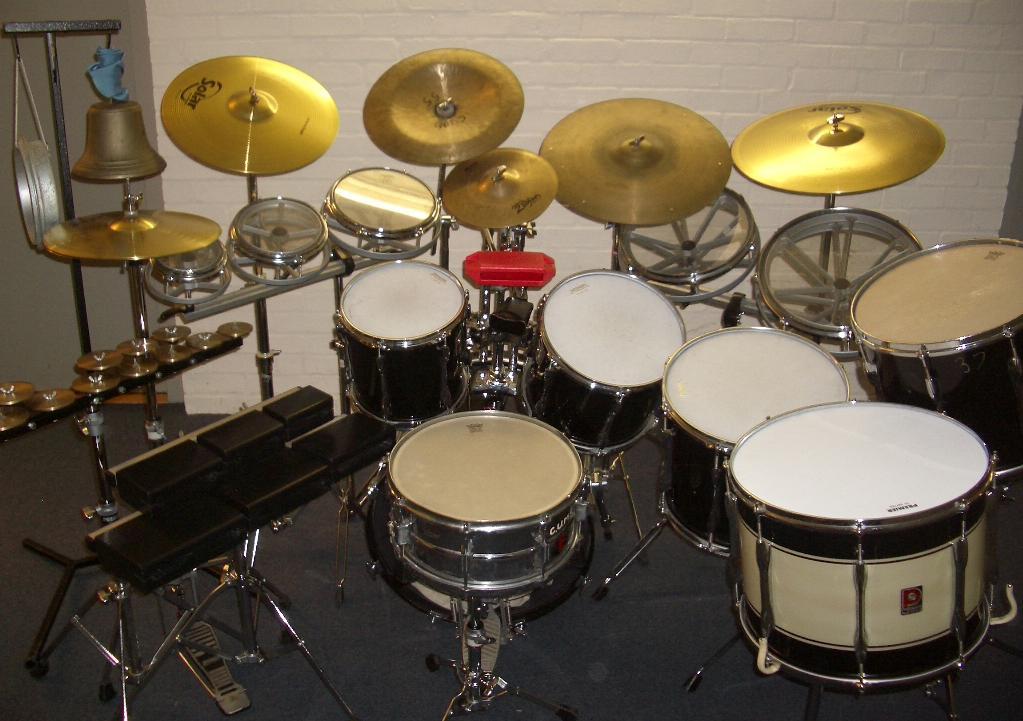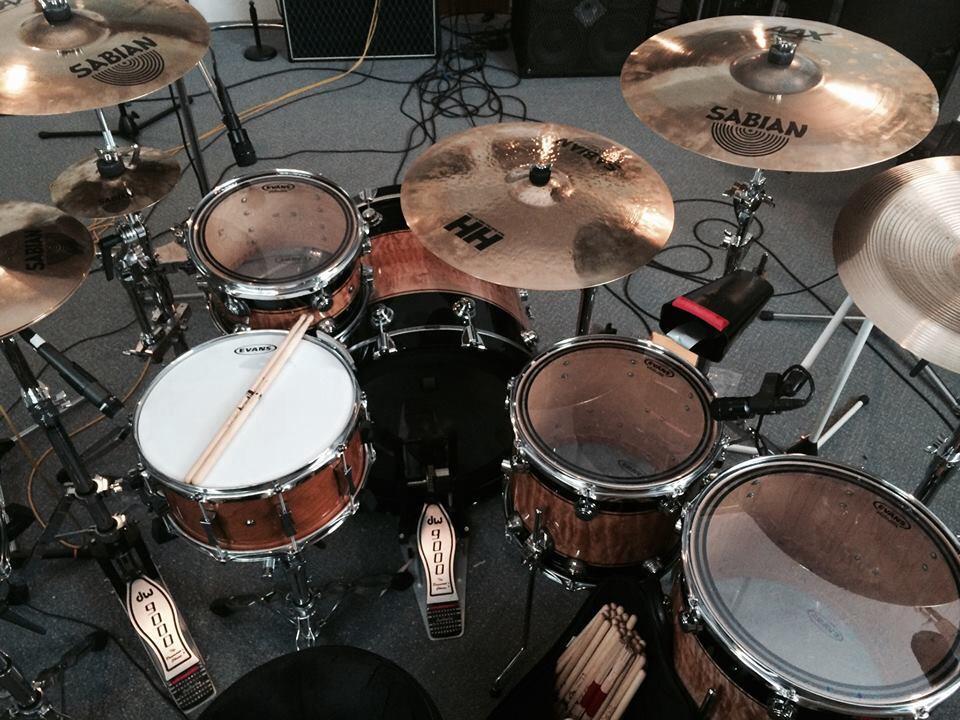The first image is the image on the left, the second image is the image on the right. Given the left and right images, does the statement "Each image contains a drum kit with multiple cymbals and cylindrical drums, but no image shows someone playing the drums." hold true? Answer yes or no. Yes. The first image is the image on the left, the second image is the image on the right. Assess this claim about the two images: "At least one human is playing an instrument.". Correct or not? Answer yes or no. No. 